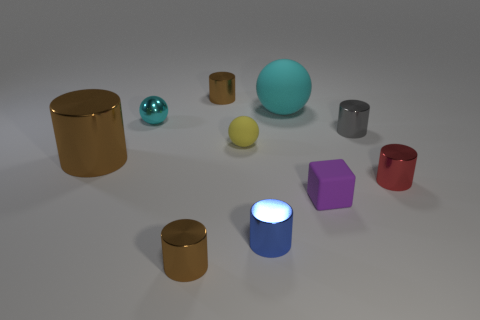Is the number of big spheres in front of the tiny blue thing less than the number of cyan balls behind the cyan rubber thing?
Your answer should be compact. No. What number of tiny brown rubber cylinders are there?
Make the answer very short. 0. The small ball that is behind the yellow sphere is what color?
Your response must be concise. Cyan. What is the size of the gray cylinder?
Your answer should be compact. Small. Do the big cylinder and the small metal cylinder in front of the small blue cylinder have the same color?
Your answer should be very brief. Yes. What is the color of the large object that is left of the blue shiny object that is in front of the yellow rubber object?
Give a very brief answer. Brown. Are there any other things that have the same size as the yellow object?
Offer a very short reply. Yes. There is a tiny matte thing behind the purple cube; is its shape the same as the big rubber thing?
Your answer should be very brief. Yes. How many small cylinders are behind the red metallic object and on the right side of the gray cylinder?
Keep it short and to the point. 0. What color is the rubber thing on the left side of the cyan ball right of the thing behind the big sphere?
Make the answer very short. Yellow. 